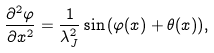<formula> <loc_0><loc_0><loc_500><loc_500>\frac { \partial ^ { 2 } \varphi } { \partial x ^ { 2 } } = \frac { 1 } { \lambda _ { J } ^ { 2 } } \sin { ( \varphi ( x ) + \theta ( x ) ) } ,</formula> 